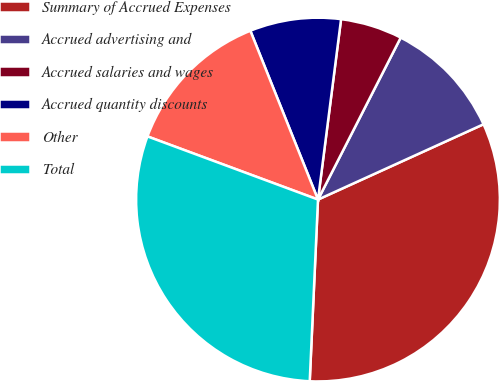<chart> <loc_0><loc_0><loc_500><loc_500><pie_chart><fcel>Summary of Accrued Expenses<fcel>Accrued advertising and<fcel>Accrued salaries and wages<fcel>Accrued quantity discounts<fcel>Other<fcel>Total<nl><fcel>32.52%<fcel>10.69%<fcel>5.49%<fcel>8.09%<fcel>13.29%<fcel>29.92%<nl></chart> 